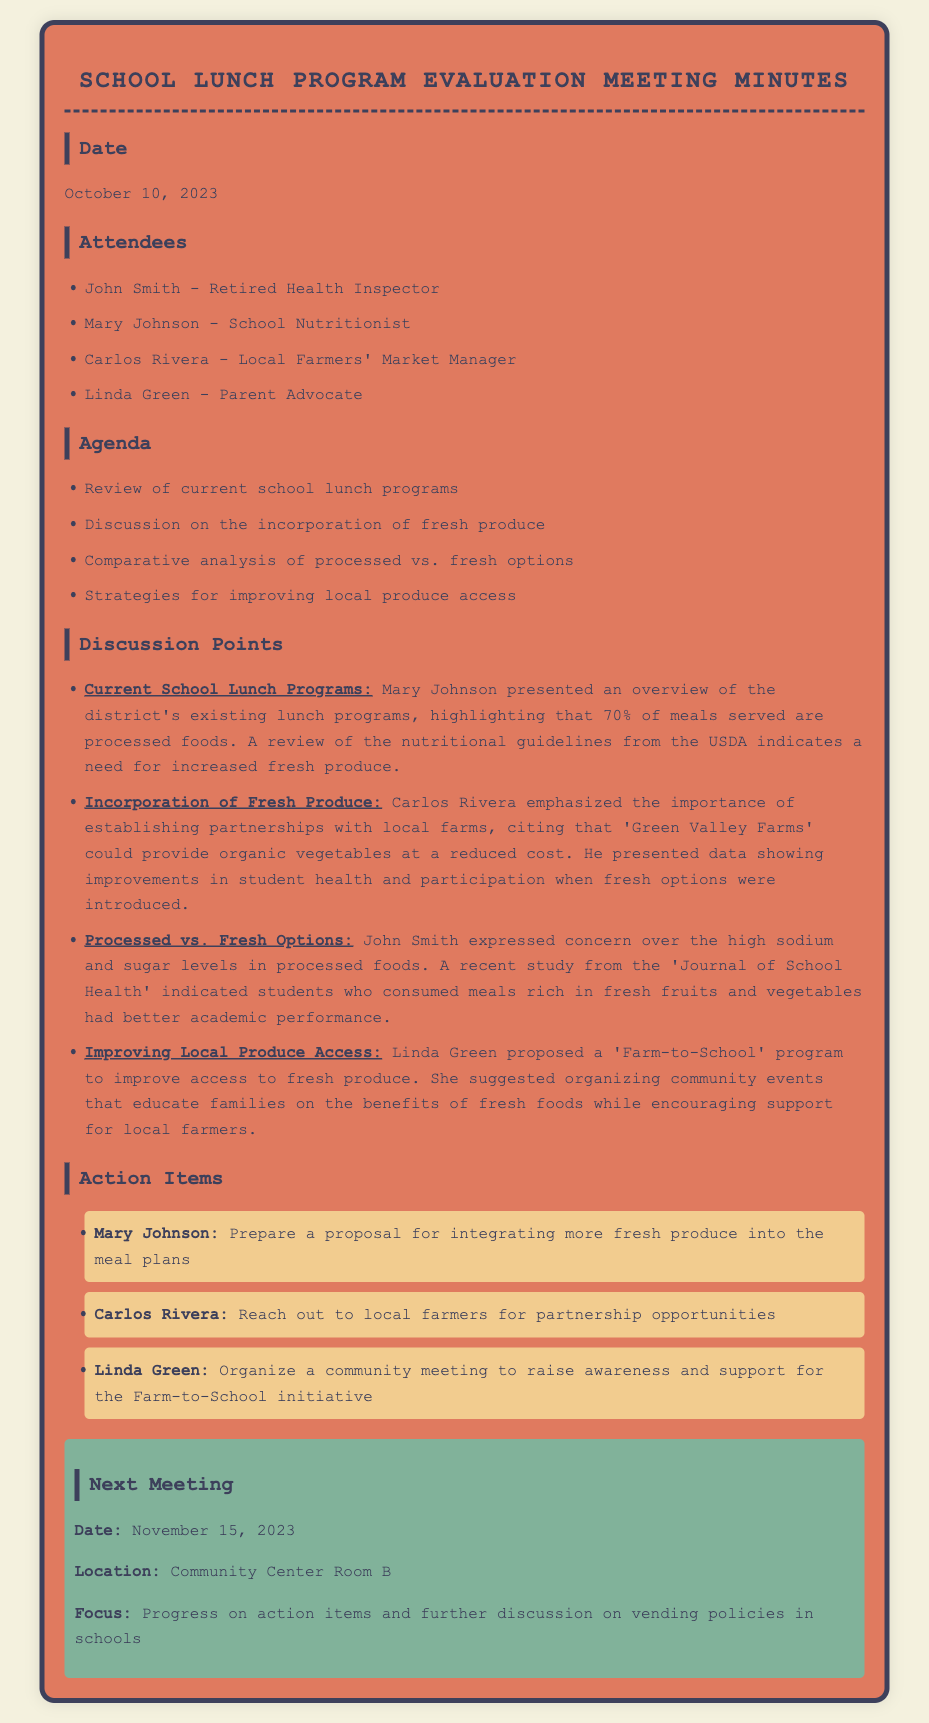What percentage of meals served are processed foods? The document states that 70% of meals served are processed foods.
Answer: 70% Who proposed the 'Farm-to-School' program? Linda Green proposed the 'Farm-to-School' program as a way to improve access to fresh produce.
Answer: Linda Green What is one reason for incorporating fresh produce according to Carlos Rivera? Carlos Rivera cited improvements in student health and participation with the introduction of fresh options.
Answer: Student health What is the date of the next meeting? The next meeting is scheduled for November 15, 2023.
Answer: November 15, 2023 What is the main focus of the upcoming meeting? The focus of the next meeting is on progress on action items and further discussion on vending policies in schools.
Answer: Progress on action items Which organization’s guidelines indicate a need for increased fresh produce? The USDA's nutritional guidelines indicate the need for increased fresh produce.
Answer: USDA What did John Smith express concern about regarding processed foods? John Smith expressed concern over the high sodium and sugar levels in processed foods.
Answer: Sodium and sugar Who is responsible for preparing a proposal for integrating more fresh produce? Mary Johnson is responsible for preparing a proposal for integrating more fresh produce into the meal plans.
Answer: Mary Johnson 